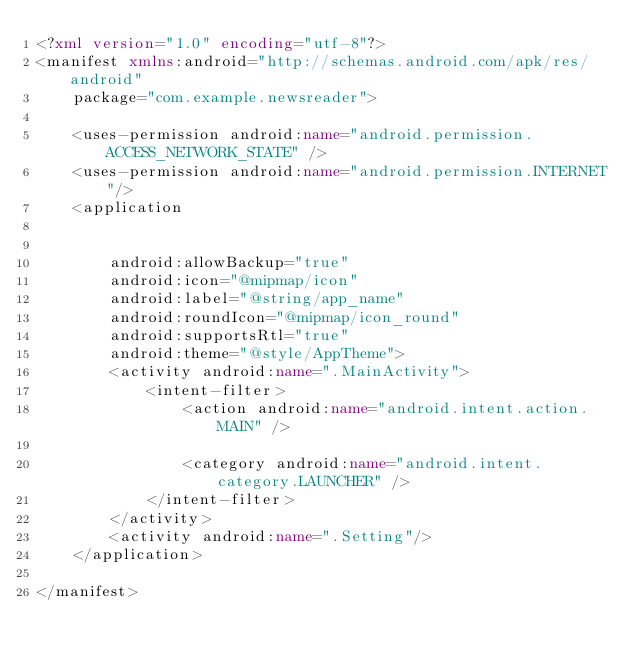<code> <loc_0><loc_0><loc_500><loc_500><_XML_><?xml version="1.0" encoding="utf-8"?>
<manifest xmlns:android="http://schemas.android.com/apk/res/android"
    package="com.example.newsreader">

    <uses-permission android:name="android.permission.ACCESS_NETWORK_STATE" />
    <uses-permission android:name="android.permission.INTERNET"/>
    <application


        android:allowBackup="true"
        android:icon="@mipmap/icon"
        android:label="@string/app_name"
        android:roundIcon="@mipmap/icon_round"
        android:supportsRtl="true"
        android:theme="@style/AppTheme">
        <activity android:name=".MainActivity">
            <intent-filter>
                <action android:name="android.intent.action.MAIN" />

                <category android:name="android.intent.category.LAUNCHER" />
            </intent-filter>
        </activity>
        <activity android:name=".Setting"/>
    </application>

</manifest></code> 